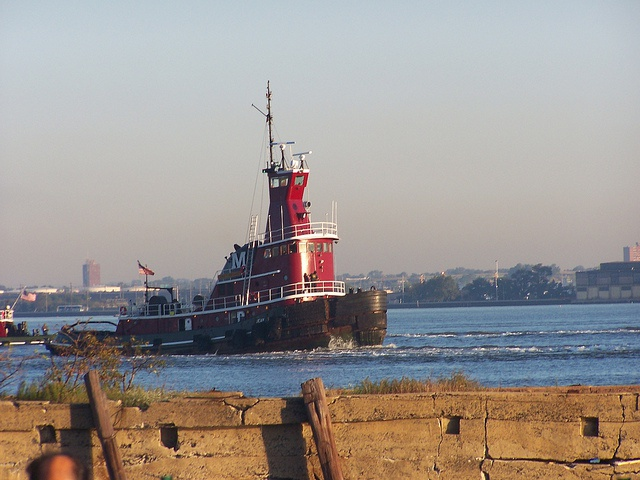Describe the objects in this image and their specific colors. I can see boat in lightgray, black, gray, darkgray, and maroon tones, boat in lightgray, black, gray, and lightpink tones, people in lightgray, black, maroon, gray, and brown tones, people in lightgray, maroon, black, brown, and purple tones, and people in lightgray, gray, navy, and black tones in this image. 